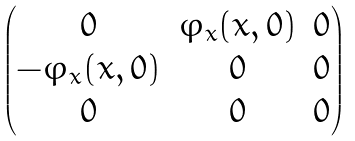<formula> <loc_0><loc_0><loc_500><loc_500>\begin{pmatrix} 0 & { \varphi _ { x } } ( x , 0 ) & 0 \\ - { \varphi _ { x } } ( x , 0 ) & 0 & 0 \\ 0 & 0 & 0 \end{pmatrix}</formula> 